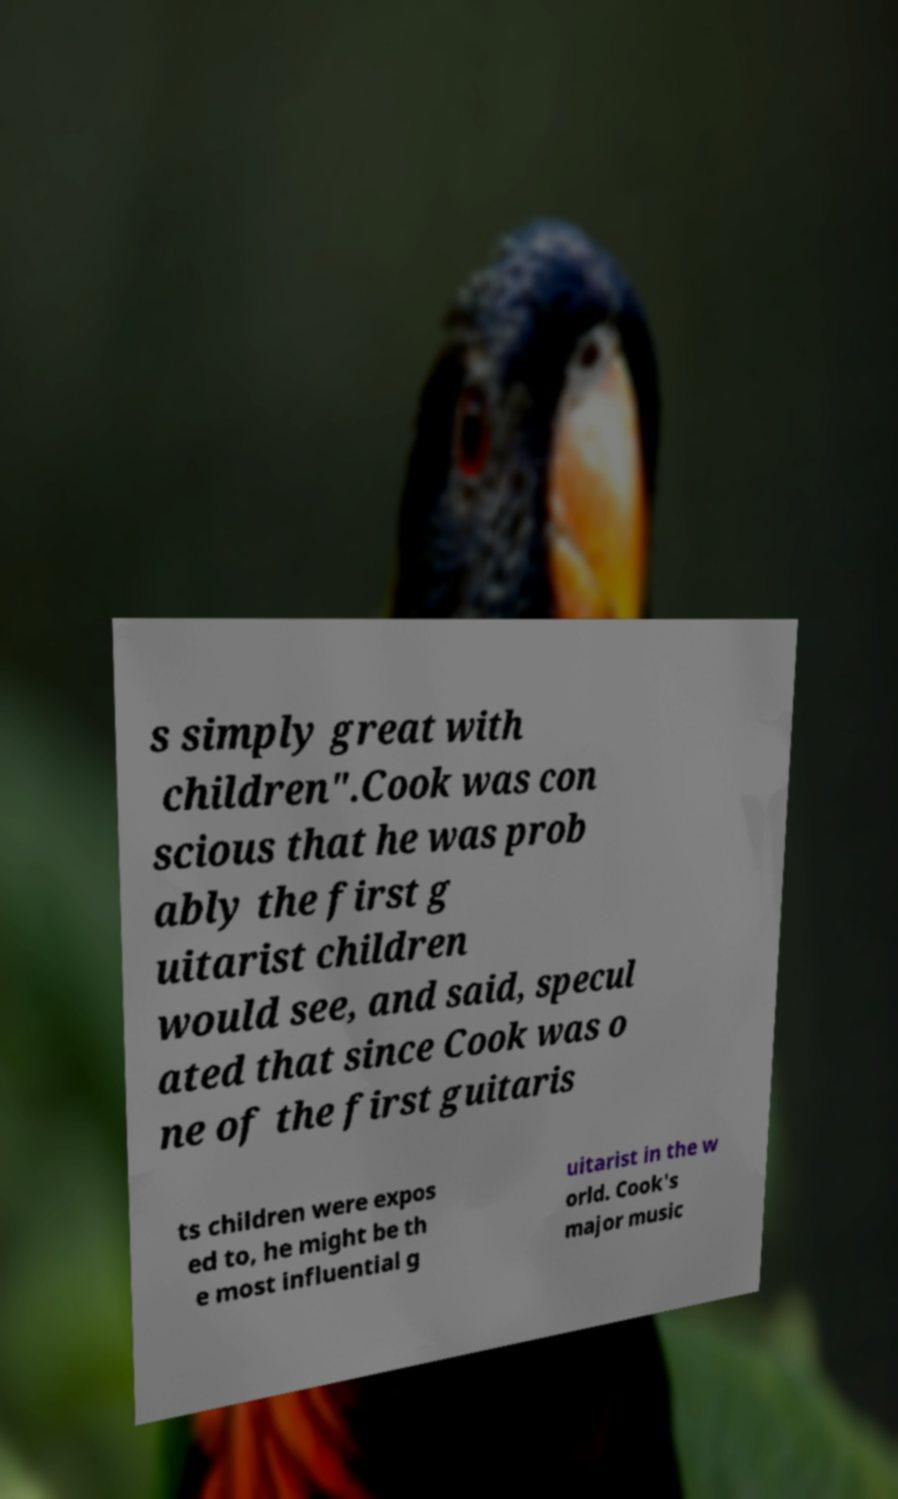Can you read and provide the text displayed in the image?This photo seems to have some interesting text. Can you extract and type it out for me? s simply great with children".Cook was con scious that he was prob ably the first g uitarist children would see, and said, specul ated that since Cook was o ne of the first guitaris ts children were expos ed to, he might be th e most influential g uitarist in the w orld. Cook's major music 